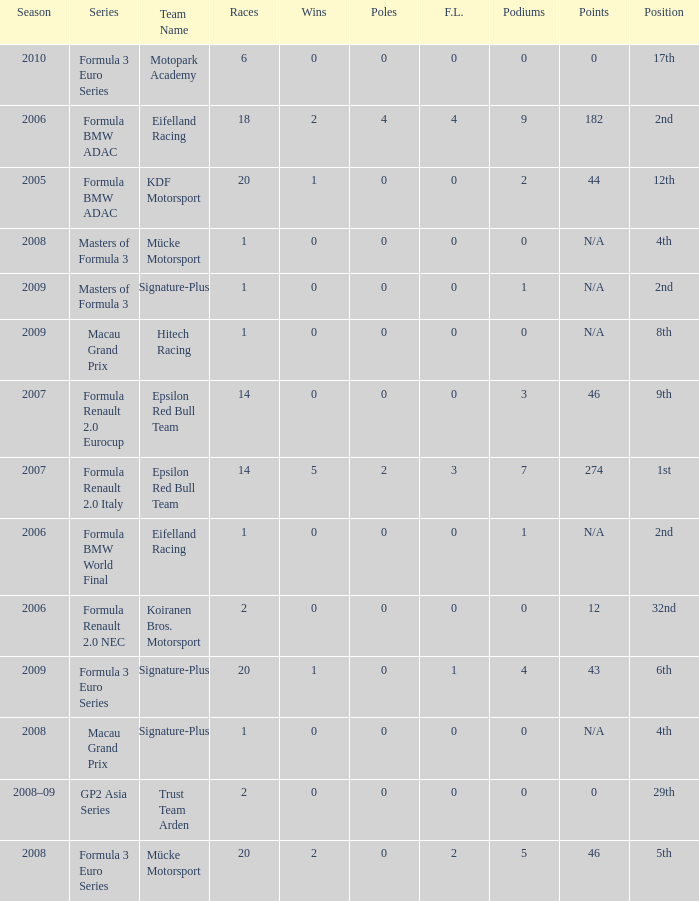What is the race in the 8th position? 1.0. 